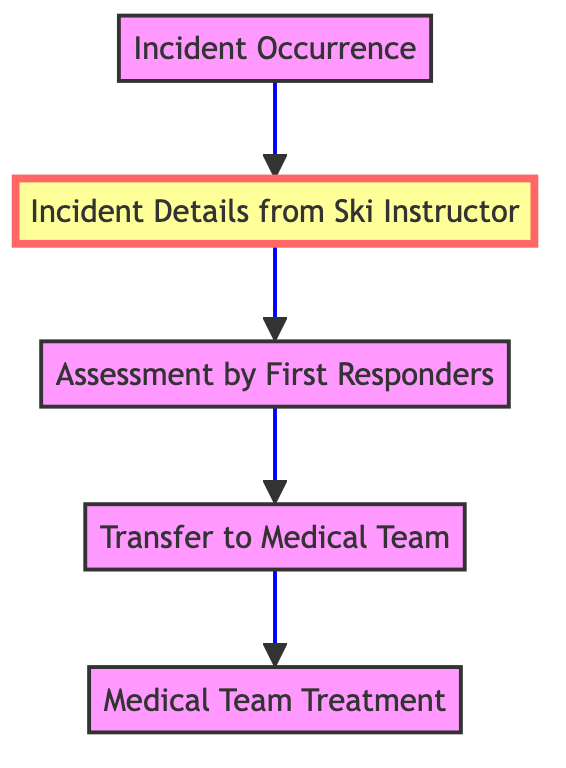What is the highest level in the diagram? The highest level in the diagram is "Medical Team Treatment," which is the final stage of the process. This can be identified as it appears at the topmost position in the flow chart.
Answer: Medical Team Treatment How many nodes are in the diagram? There are five nodes in total, each representing a distinct step in the incident report process. This count includes nodes starting from the incident occurrence to the final treatment by the medical team.
Answer: 5 Which node provides incident details? The node providing incident details is "Incident Details from Ski Instructor," as indicated by its description in the diagram. It is directly connected to the incident occurrence proceeding the assessment by first responders.
Answer: Incident Details from Ski Instructor What is the second step in the incident report process? The second step in the process is "Assessment by First Responders," which follows the receipt of incident details from the ski instructor. This sequence outlines how the response team evaluates the skier’s condition.
Answer: Assessment by First Responders Which two nodes are directly connected? The nodes directly connected are "Incident Occurrence" and "Incident Details from Ski Instructor," as indicated by the arrow leading from the occurrence to the collection of incident details.
Answer: Incident Occurrence and Incident Details from Ski Instructor What action follows the assessment of first responders? The action that follows the assessment is the "Transfer to Medical Team," which signifies the transition of the skier to receive appropriate medical care based on the assessment outcome.
Answer: Transfer to Medical Team What is the flow direction of the diagram? The flow direction of the diagram is upward, indicating a progression from the incident occurrence at the bottom to the medical team treatment at the top. This upward flow symbolically represents the movement towards resolution and care.
Answer: Upward Which node emphasizes information provided by the ski instructor? The node that emphasizes information provided by the ski instructor is "Incident Details from Ski Instructor," marked with a highlight in the diagram, indicating its significance in the process.
Answer: Incident Details from Ski Instructor 